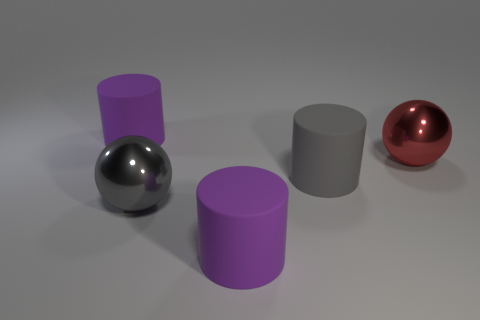Are there an equal number of purple matte cylinders right of the large gray matte thing and big gray matte things that are on the right side of the big red sphere?
Keep it short and to the point. Yes. What material is the large thing right of the gray matte thing?
Make the answer very short. Metal. How many things are big cylinders that are behind the big red metallic object or large cylinders?
Provide a succinct answer. 3. What number of other objects are the same shape as the gray rubber thing?
Make the answer very short. 2. Does the metallic thing that is right of the gray cylinder have the same shape as the large gray matte object?
Your answer should be very brief. No. There is a gray shiny ball; are there any red shiny objects in front of it?
Make the answer very short. No. How many tiny objects are either gray cylinders or red shiny balls?
Offer a terse response. 0. Does the red sphere have the same material as the large gray cylinder?
Offer a terse response. No. What is the size of the other sphere that is the same material as the big gray sphere?
Offer a terse response. Large. There is a big shiny thing left of the big purple object that is on the right side of the rubber thing that is to the left of the big gray metal thing; what shape is it?
Make the answer very short. Sphere. 